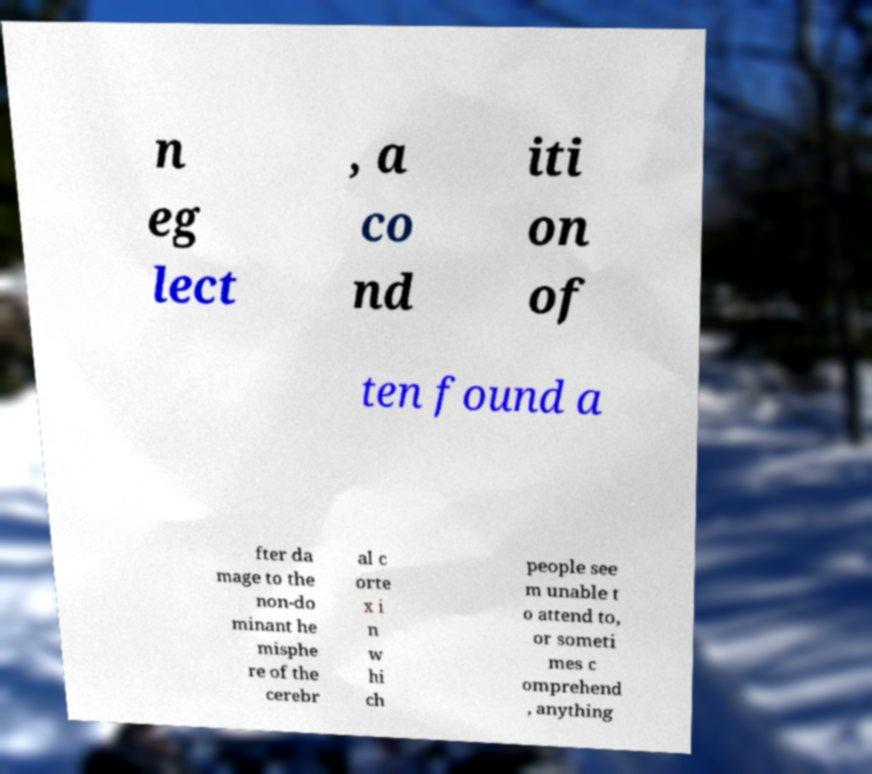Can you accurately transcribe the text from the provided image for me? n eg lect , a co nd iti on of ten found a fter da mage to the non-do minant he misphe re of the cerebr al c orte x i n w hi ch people see m unable t o attend to, or someti mes c omprehend , anything 